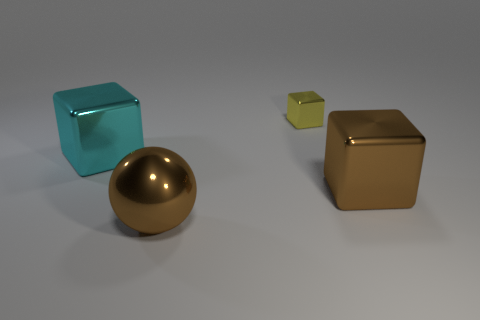There is a brown metal object that is right of the yellow thing; is it the same size as the small yellow thing?
Provide a short and direct response. No. Are there fewer small yellow shiny things than tiny gray metal cylinders?
Ensure brevity in your answer.  No. What is the shape of the large brown thing that is on the right side of the metallic block that is behind the big metal cube on the left side of the small shiny cube?
Make the answer very short. Cube. Are there any yellow objects made of the same material as the large cyan object?
Your answer should be compact. Yes. There is a shiny object right of the small metallic cube; is it the same color as the shiny thing on the left side of the big brown ball?
Provide a succinct answer. No. Are there fewer large brown metallic cubes that are in front of the big ball than big cyan things?
Provide a short and direct response. Yes. What number of objects are cyan blocks or large objects that are on the left side of the brown shiny ball?
Provide a short and direct response. 1. What color is the big sphere that is made of the same material as the big cyan object?
Provide a short and direct response. Brown. What number of objects are either big cyan cubes or large brown metallic blocks?
Give a very brief answer. 2. What color is the shiny ball that is the same size as the cyan shiny object?
Provide a succinct answer. Brown. 